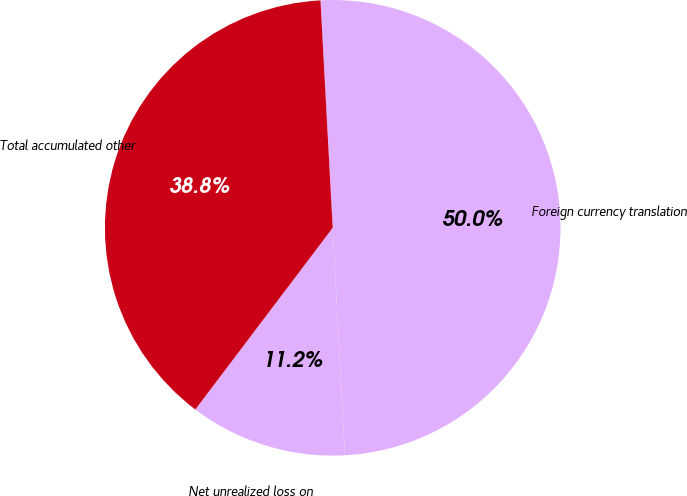Convert chart to OTSL. <chart><loc_0><loc_0><loc_500><loc_500><pie_chart><fcel>Net unrealized loss on<fcel>Foreign currency translation<fcel>Total accumulated other<nl><fcel>11.16%<fcel>50.0%<fcel>38.84%<nl></chart> 